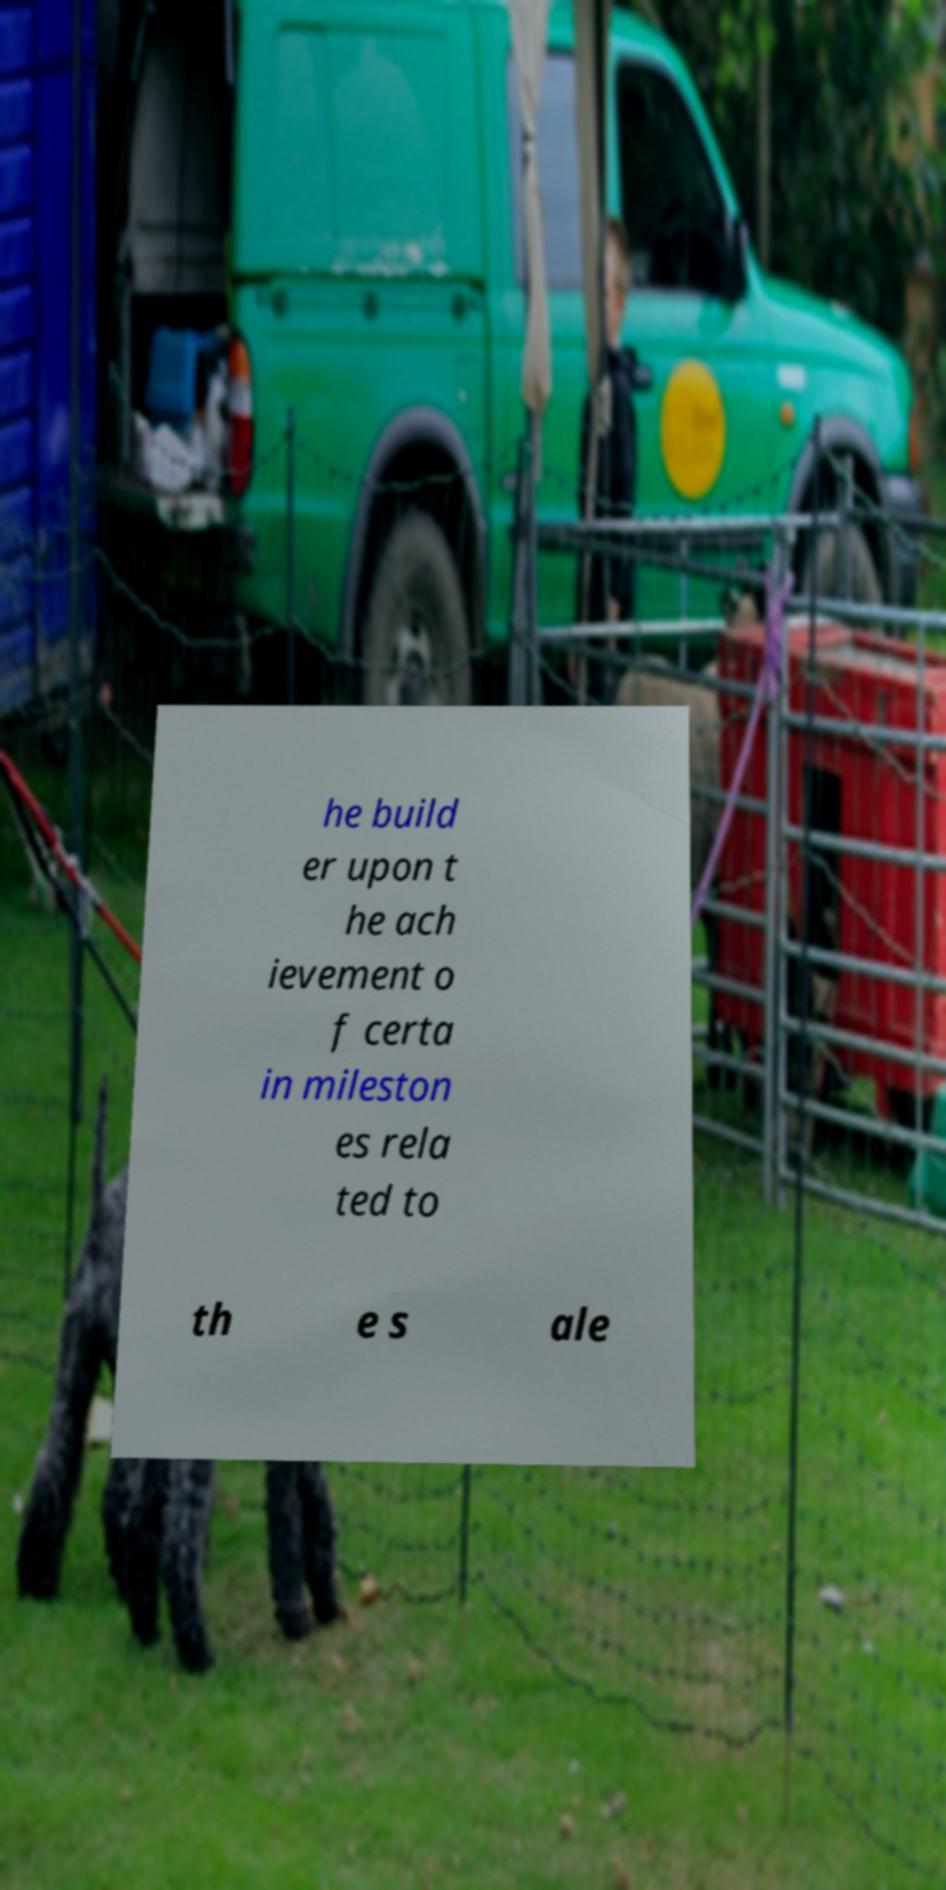Could you assist in decoding the text presented in this image and type it out clearly? he build er upon t he ach ievement o f certa in mileston es rela ted to th e s ale 